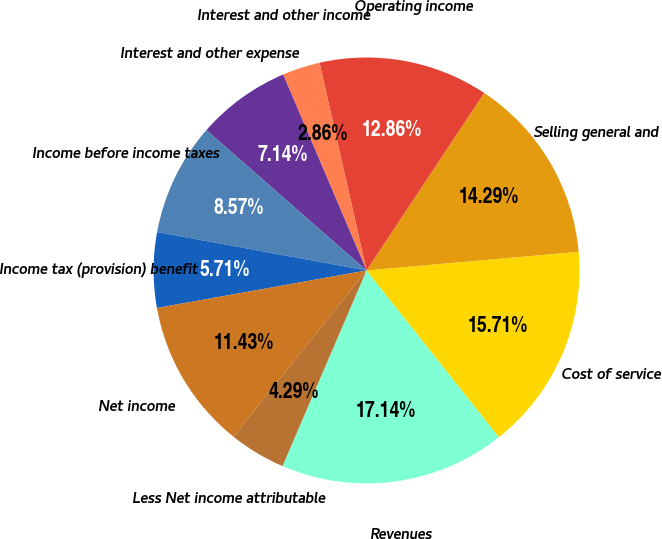Convert chart to OTSL. <chart><loc_0><loc_0><loc_500><loc_500><pie_chart><fcel>Revenues<fcel>Cost of service<fcel>Selling general and<fcel>Operating income<fcel>Interest and other income<fcel>Interest and other expense<fcel>Income before income taxes<fcel>Income tax (provision) benefit<fcel>Net income<fcel>Less Net income attributable<nl><fcel>17.14%<fcel>15.71%<fcel>14.29%<fcel>12.86%<fcel>2.86%<fcel>7.14%<fcel>8.57%<fcel>5.71%<fcel>11.43%<fcel>4.29%<nl></chart> 